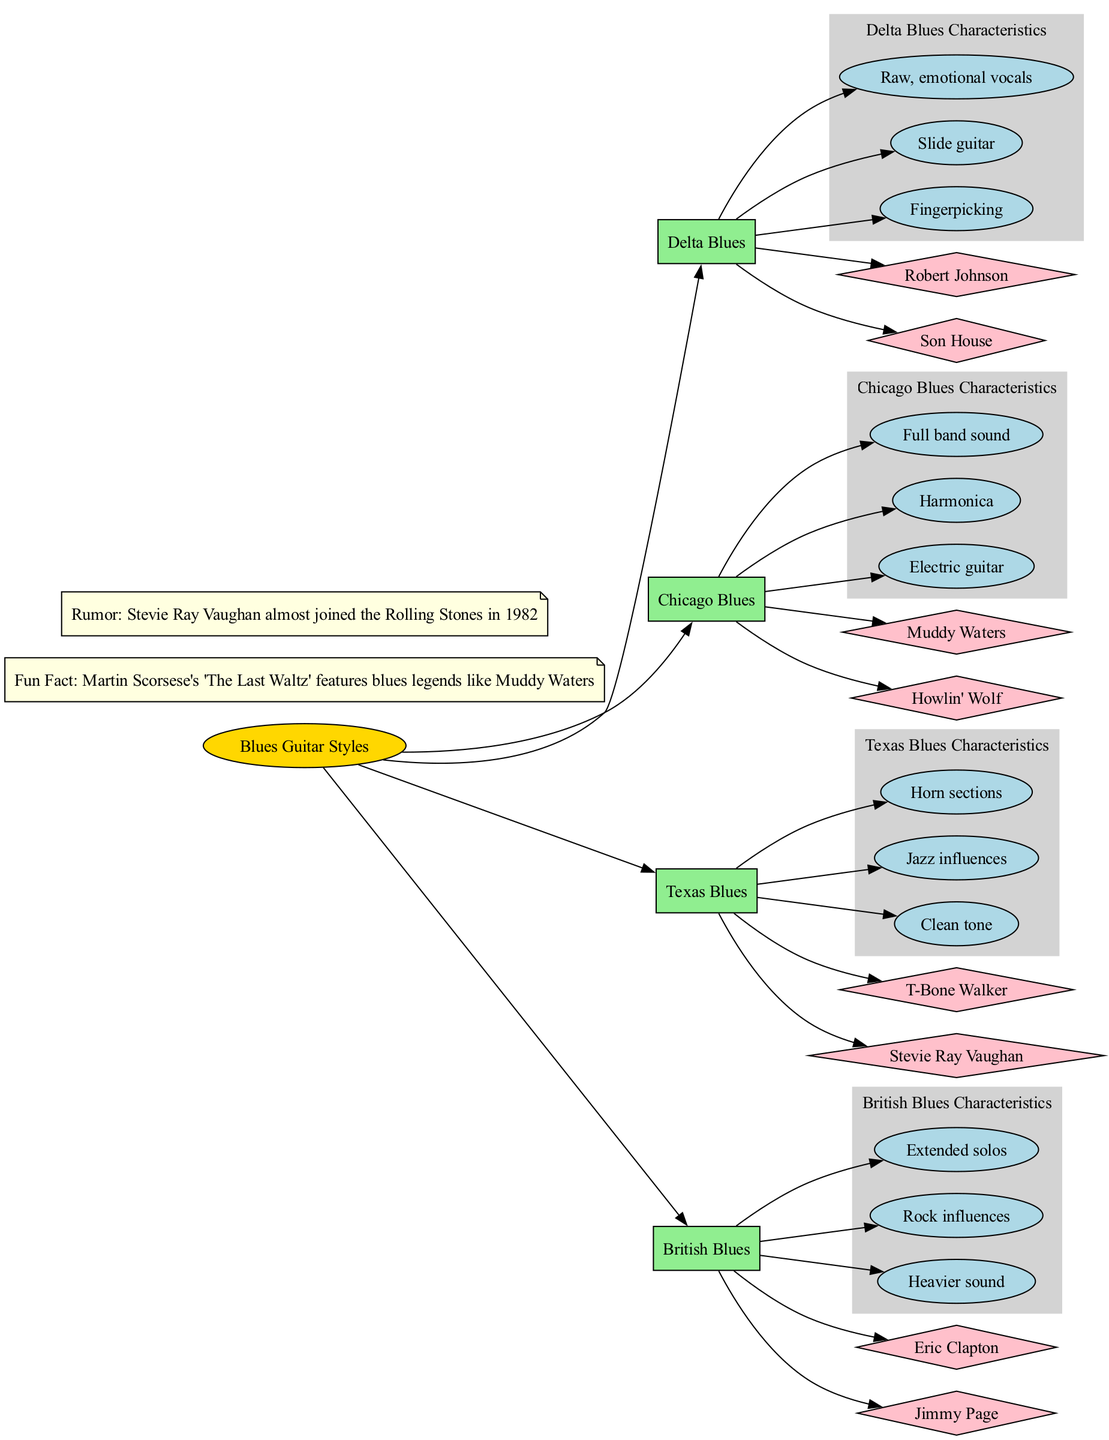What's the first style listed in the diagram? The diagram presents the styles in a specific order. The first style mentioned is Delta Blues.
Answer: Delta Blues How many characteristics does Chicago Blues have? By listing the characteristics under Chicago Blues in the diagram, we can see there are three characteristics detailed.
Answer: 3 Who is a notable artist of Texas Blues? Looking at the notable artists under Texas Blues, T-Bone Walker is one of the artists listed.
Answer: T-Bone Walker What type of sound is associated with British Blues? The characteristics listed for British Blues include "Heavier sound," which directly answers the question.
Answer: Heavier sound Which style is known for the use of harmonica? By examining the characteristics of Chicago Blues, one can find that harmonica is explicitly mentioned as a key element.
Answer: Chicago Blues What is a common characteristic of both Delta Blues and Chicago Blues? Both styles share the common element of emotional expression through vocals, a theme throughout their characteristics.
Answer: Emotional vocals How many notable artists are listed for Delta Blues? The diagram states there are two notable artists for Delta Blues, which can be counted directly from the information provided.
Answer: 2 Which blues style features jazz influences? The specific characteristics for Texas Blues mention "Jazz influences," marking it as the accurate response to the inquiry.
Answer: Texas Blues What color represents the characteristics nodes in the diagram? The characteristic nodes are indicated as light grey in the diagram, which reflects their designated color theme.
Answer: Light grey 